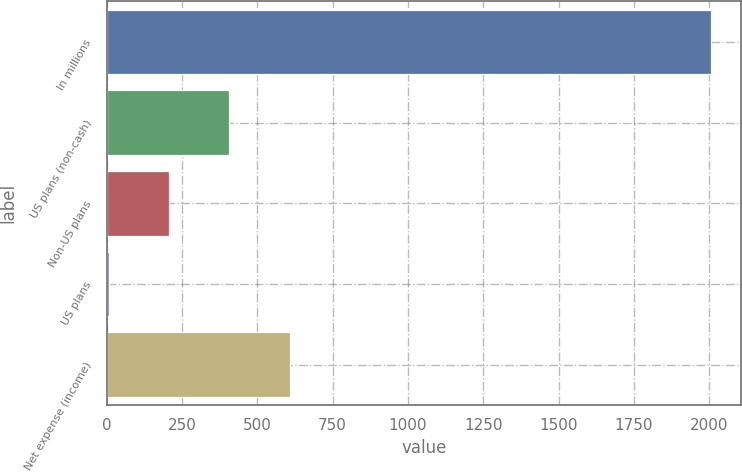Convert chart. <chart><loc_0><loc_0><loc_500><loc_500><bar_chart><fcel>In millions<fcel>US plans (non-cash)<fcel>Non-US plans<fcel>US plans<fcel>Net expense (income)<nl><fcel>2006<fcel>406.8<fcel>206.9<fcel>7<fcel>606.7<nl></chart> 